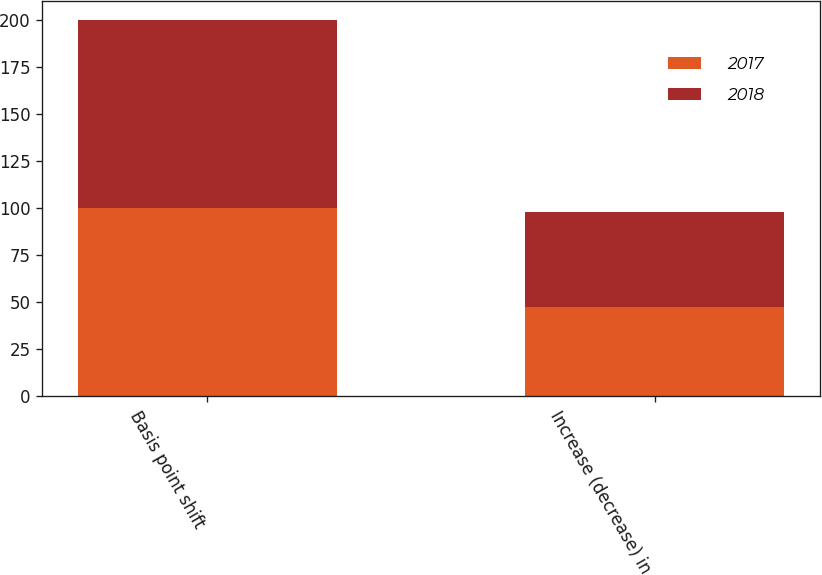Convert chart to OTSL. <chart><loc_0><loc_0><loc_500><loc_500><stacked_bar_chart><ecel><fcel>Basis point shift<fcel>Increase (decrease) in<nl><fcel>2017<fcel>100<fcel>47<nl><fcel>2018<fcel>100<fcel>51<nl></chart> 